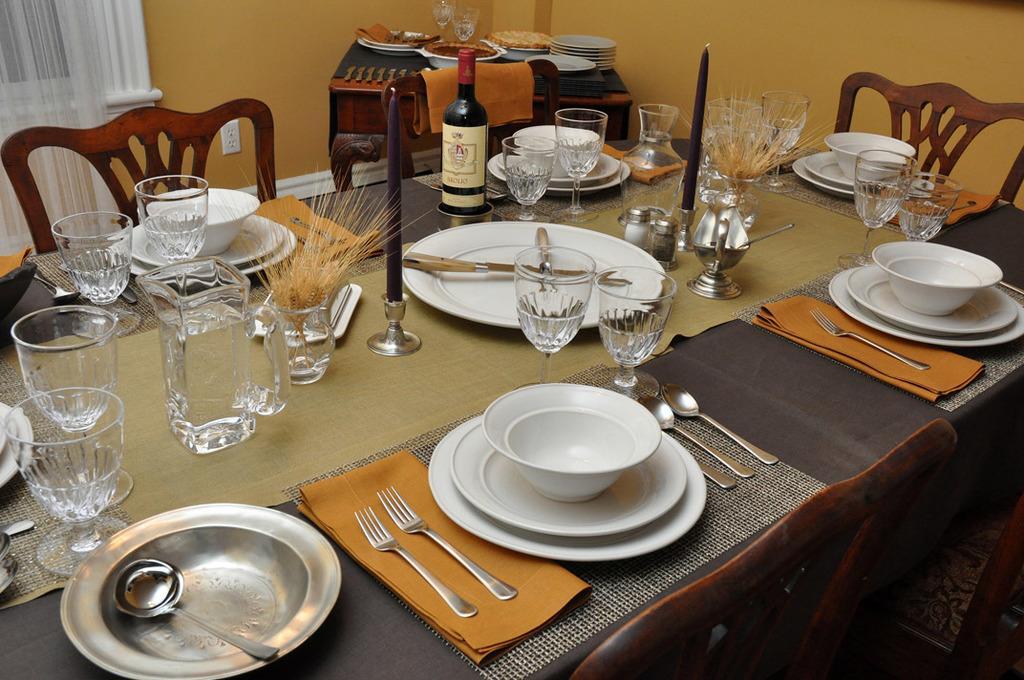Could you give a brief overview of what you see in this image? This is the table with candle with a candle stand,plates,bowls,wine glasses,water jug,spoons,forks,and some other things. These are the empty chairs. Here I can find another small table with food and plates on it. At background i can see curtain hanging. 